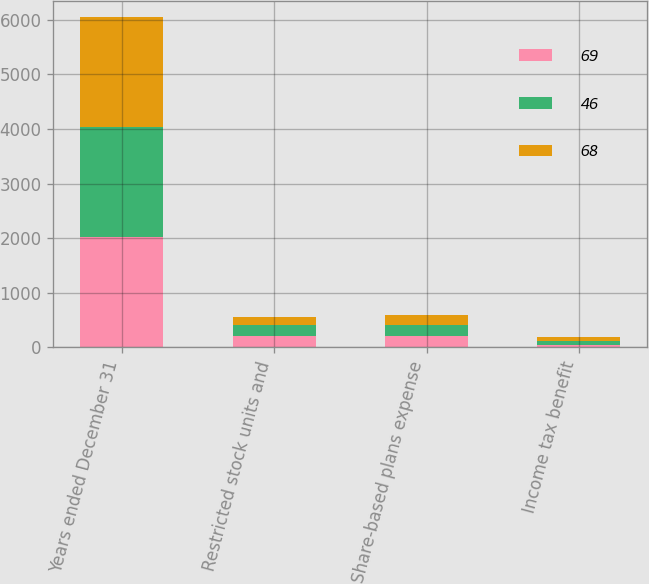Convert chart to OTSL. <chart><loc_0><loc_0><loc_500><loc_500><stacked_bar_chart><ecel><fcel>Years ended December 31<fcel>Restricted stock units and<fcel>Share-based plans expense<fcel>Income tax benefit<nl><fcel>69<fcel>2017<fcel>212<fcel>212<fcel>46<nl><fcel>46<fcel>2016<fcel>189<fcel>193<fcel>69<nl><fcel>68<fcel>2015<fcel>160<fcel>190<fcel>68<nl></chart> 